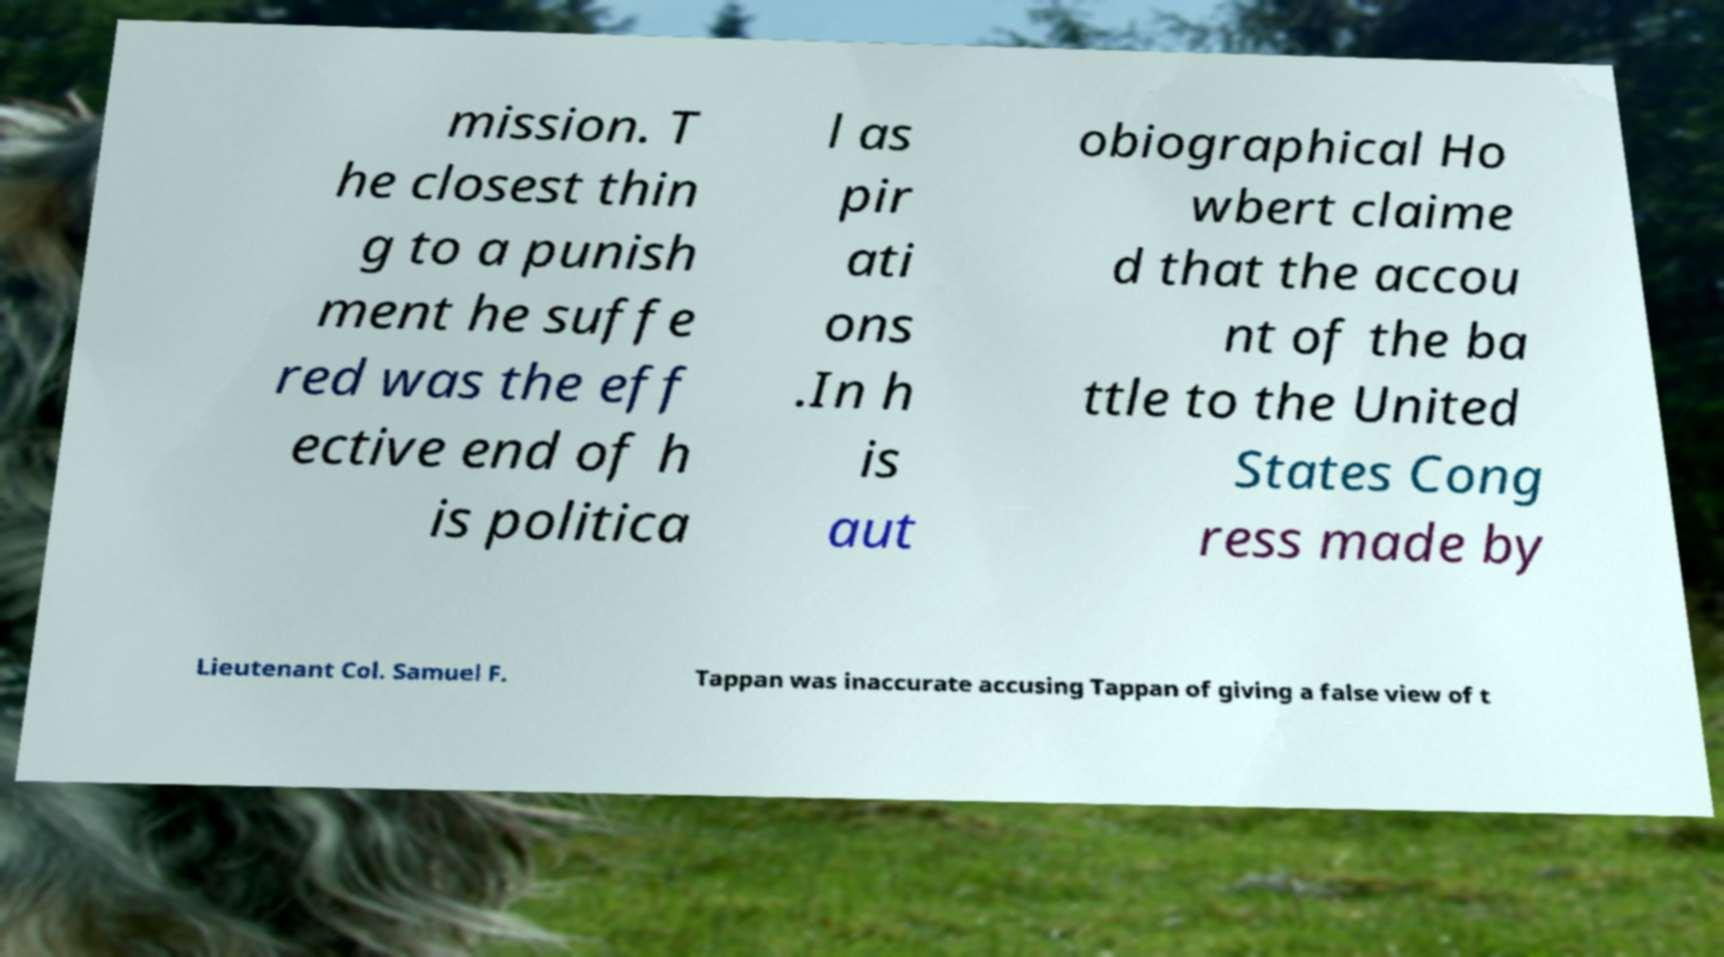What messages or text are displayed in this image? I need them in a readable, typed format. mission. T he closest thin g to a punish ment he suffe red was the eff ective end of h is politica l as pir ati ons .In h is aut obiographical Ho wbert claime d that the accou nt of the ba ttle to the United States Cong ress made by Lieutenant Col. Samuel F. Tappan was inaccurate accusing Tappan of giving a false view of t 